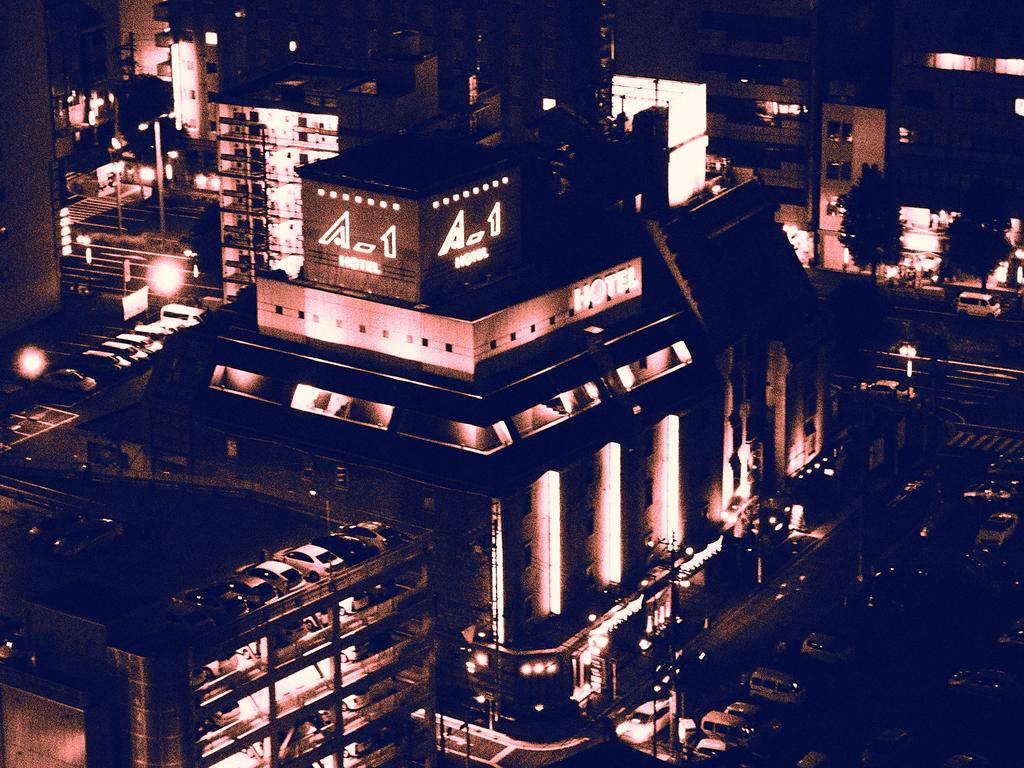What is the primary subject of the image? The primary subject of the image is the many buildings. Can you describe the vehicles visible in the image? There are vehicles visible on the road in the bottom right-hand corner of the image. What sense is being stimulated by the buildings in the image? The image is visual, so the sense being stimulated is sight. However, the buildings themselves do not stimulate a specific sense beyond sight. What type of planes can be seen flying over the buildings in the image? There are no planes visible in the image; only buildings and vehicles on the road are present. 